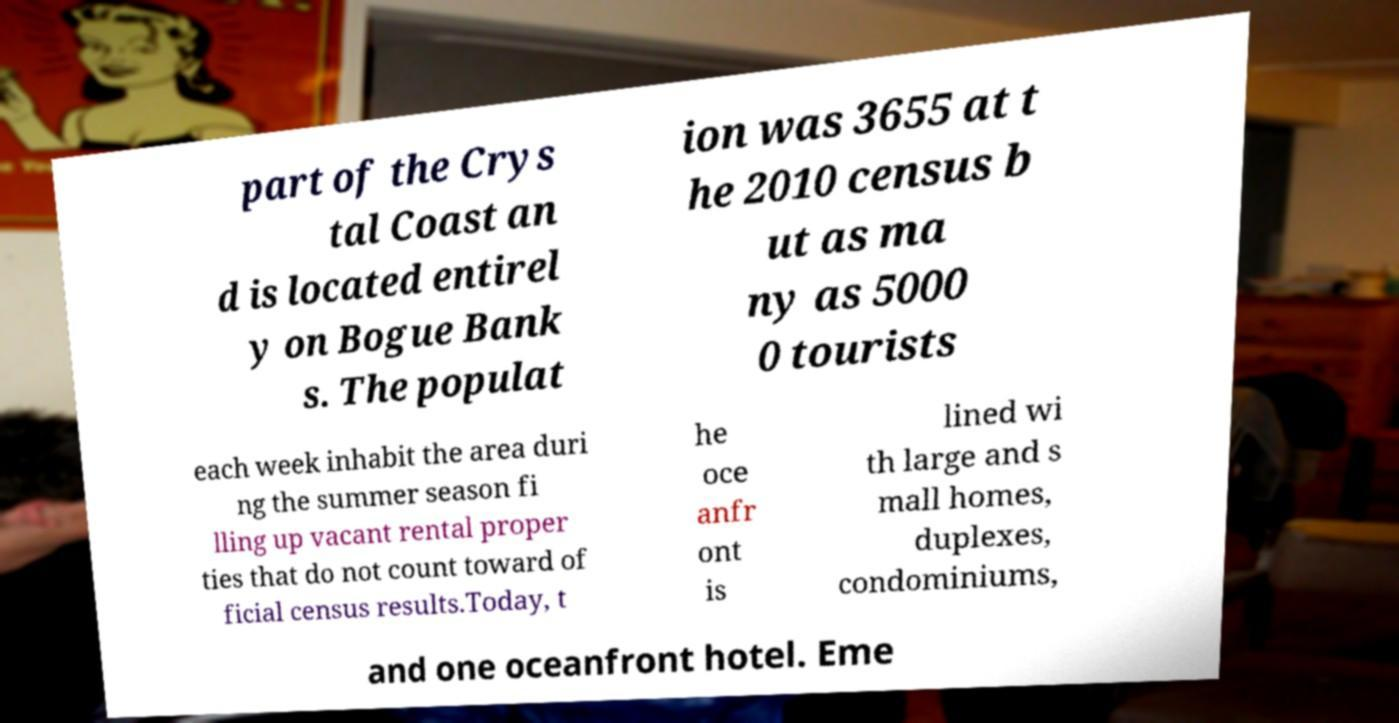There's text embedded in this image that I need extracted. Can you transcribe it verbatim? part of the Crys tal Coast an d is located entirel y on Bogue Bank s. The populat ion was 3655 at t he 2010 census b ut as ma ny as 5000 0 tourists each week inhabit the area duri ng the summer season fi lling up vacant rental proper ties that do not count toward of ficial census results.Today, t he oce anfr ont is lined wi th large and s mall homes, duplexes, condominiums, and one oceanfront hotel. Eme 